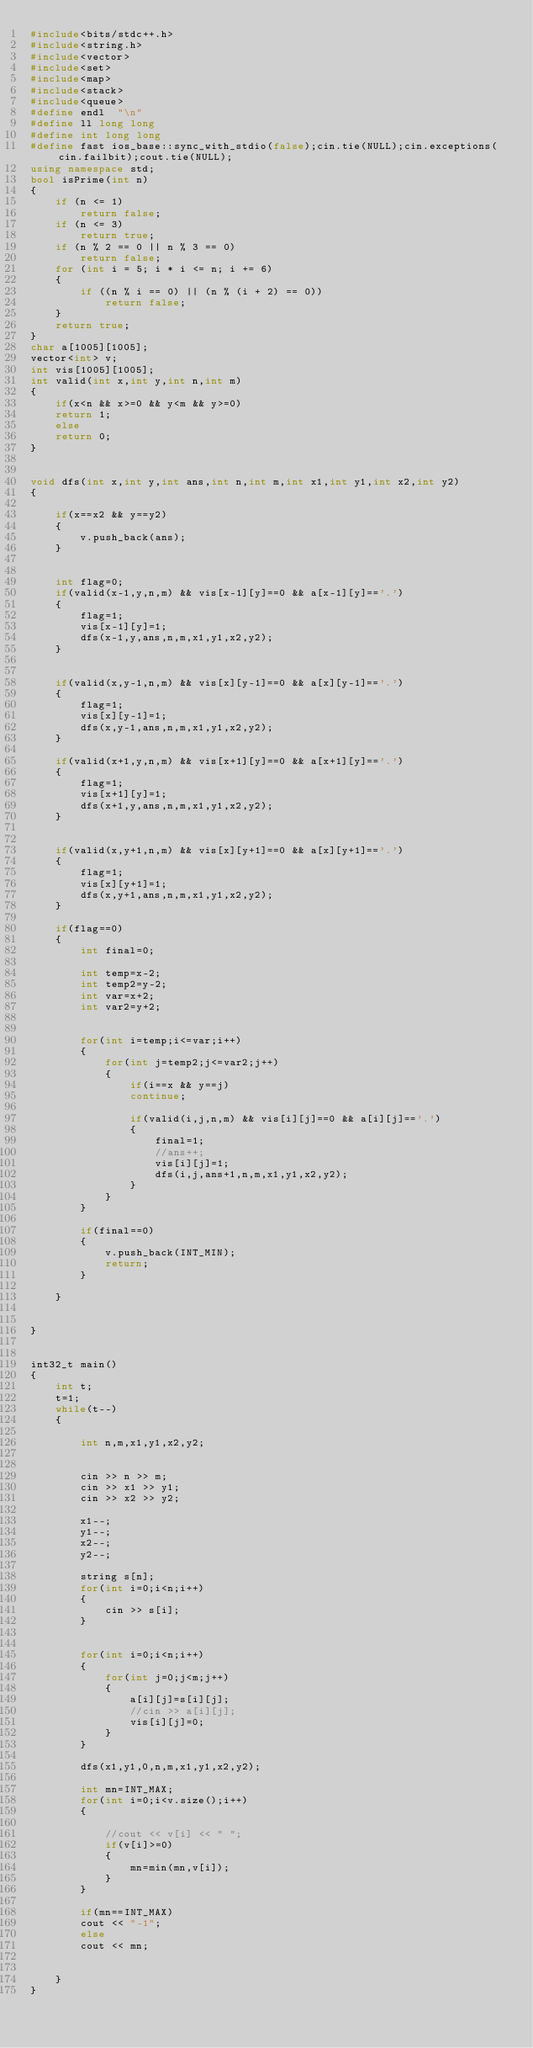<code> <loc_0><loc_0><loc_500><loc_500><_C++_>#include<bits/stdc++.h>
#include<string.h>
#include<vector>
#include<set>
#include<map>
#include<stack>
#include<queue>
#define endl  "\n"
#define ll long long
#define int long long
#define fast ios_base::sync_with_stdio(false);cin.tie(NULL);cin.exceptions(cin.failbit);cout.tie(NULL);
using namespace std;
bool isPrime(int n)
{
    if (n <= 1)
        return false;
    if (n <= 3)
        return true;
    if (n % 2 == 0 || n % 3 == 0)
        return false;
    for (int i = 5; i * i <= n; i += 6)
    {
        if ((n % i == 0) || (n % (i + 2) == 0))
            return false;
    }
    return true;
}
char a[1005][1005];
vector<int> v;
int vis[1005][1005];
int valid(int x,int y,int n,int m)
{
	if(x<n && x>=0 && y<m && y>=0)
	return 1;
	else
	return 0;
}


void dfs(int x,int y,int ans,int n,int m,int x1,int y1,int x2,int y2)
{
	
	if(x==x2 && y==y2)
	{
		v.push_back(ans);
	}
	
	
	int flag=0;
	if(valid(x-1,y,n,m) && vis[x-1][y]==0 && a[x-1][y]=='.')
	{
		flag=1;
		vis[x-1][y]=1;
		dfs(x-1,y,ans,n,m,x1,y1,x2,y2);
	}
	
	
	if(valid(x,y-1,n,m) && vis[x][y-1]==0 && a[x][y-1]=='.')
	{
		flag=1;
		vis[x][y-1]=1;
		dfs(x,y-1,ans,n,m,x1,y1,x2,y2);
	}
	
	if(valid(x+1,y,n,m) && vis[x+1][y]==0 && a[x+1][y]=='.')
	{
		flag=1;
		vis[x+1][y]=1;
		dfs(x+1,y,ans,n,m,x1,y1,x2,y2);
	}
	
	
	if(valid(x,y+1,n,m) && vis[x][y+1]==0 && a[x][y+1]=='.')
	{
		flag=1;
		vis[x][y+1]=1;
		dfs(x,y+1,ans,n,m,x1,y1,x2,y2);
	}
	
	if(flag==0)
	{
		int final=0;
		
		int temp=x-2;
		int temp2=y-2;
		int var=x+2;
		int var2=y+2;
		
		
		for(int i=temp;i<=var;i++)
		{
			for(int j=temp2;j<=var2;j++)
			{
				if(i==x && y==j)
				continue;
				
				if(valid(i,j,n,m) && vis[i][j]==0 && a[i][j]=='.')
				{
					final=1;
					//ans++;
					vis[i][j]=1;
					dfs(i,j,ans+1,n,m,x1,y1,x2,y2);
				}
			}
		}
		
		if(final==0)
		{	
			v.push_back(INT_MIN);
			return;
		}
		
	}
	
	
}


int32_t main()
{
	int t;
	t=1;
	while(t--)
	{
		
		int n,m,x1,y1,x2,y2;

		
		cin >> n >> m;
		cin >> x1 >> y1;
		cin >> x2 >> y2;
		
		x1--;
		y1--;
		x2--;
		y2--;
		
		string s[n];
		for(int i=0;i<n;i++)
		{
			cin >> s[i];
		}
		
		
		for(int i=0;i<n;i++)
		{
			for(int j=0;j<m;j++)
			{
				a[i][j]=s[i][j];
				//cin >> a[i][j];
				vis[i][j]=0;
			}
		}
		
		dfs(x1,y1,0,n,m,x1,y1,x2,y2);
		
		int mn=INT_MAX;
		for(int i=0;i<v.size();i++)
		{
			
			//cout << v[i] << " ";
			if(v[i]>=0)
			{
				mn=min(mn,v[i]);
			}
		}
		
		if(mn==INT_MAX)
		cout << "-1";
		else
		cout << mn;
		
		
	}
}


</code> 